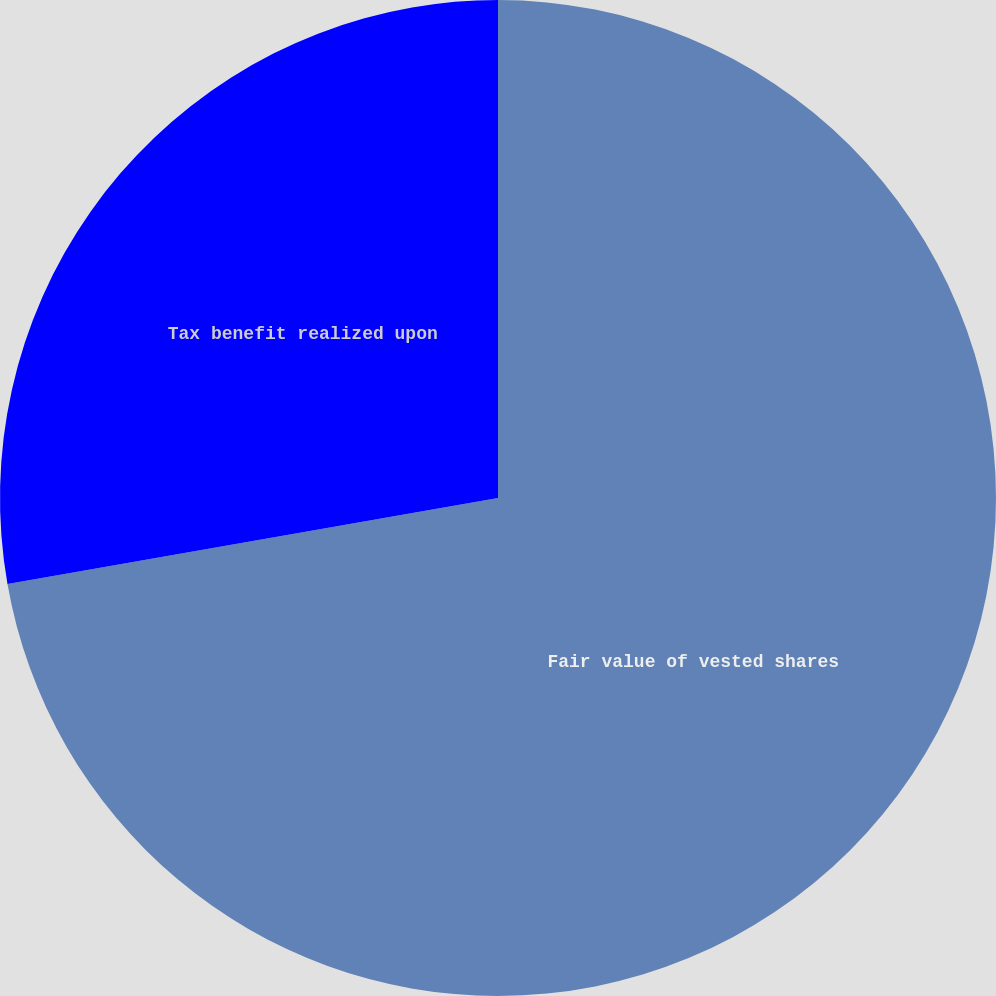<chart> <loc_0><loc_0><loc_500><loc_500><pie_chart><fcel>Fair value of vested shares<fcel>Tax benefit realized upon<nl><fcel>72.24%<fcel>27.76%<nl></chart> 